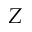Convert formula to latex. <formula><loc_0><loc_0><loc_500><loc_500>Z</formula> 